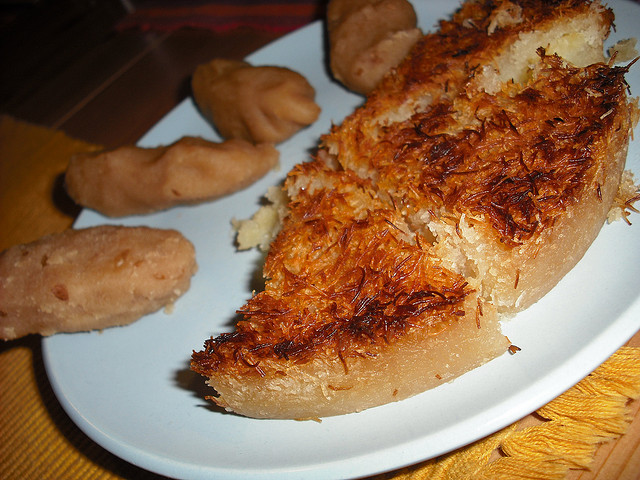<image>What kind of food is shown? I am not sure. The food shown could be either bread, pizza, pie and pastries, quiche, pizza and wontons, or cheesecake. What kind of food is shown? I don't know what kind of food is shown. It can be bread, pizza, pie and pastries, quiche, or cheesecake. 